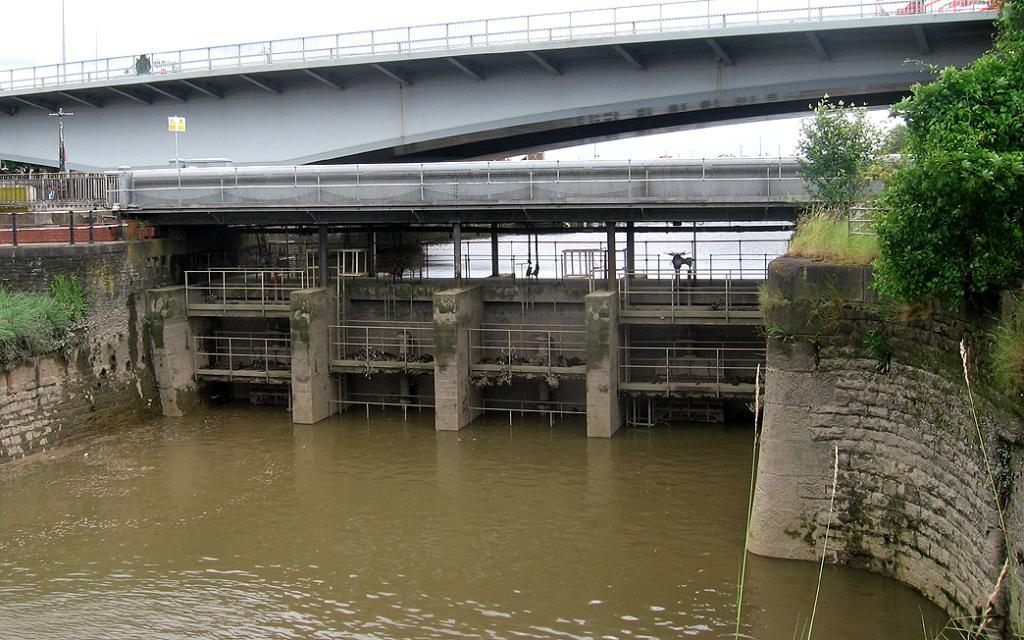What structures are present in the image to control water flow? There are dam gates in the image to control water flow. What is happening to the water in the image? Water is flowing in the image. What type of infrastructure is present in the image for crossing the water? There is a bridge in the image for crossing the water. What type of vegetation can be seen in the image? Trees and plants are visible in the image. How many legs can be seen on the fish in the image? There are no fish present in the image, so it is not possible to determine the number of legs on a fish. 